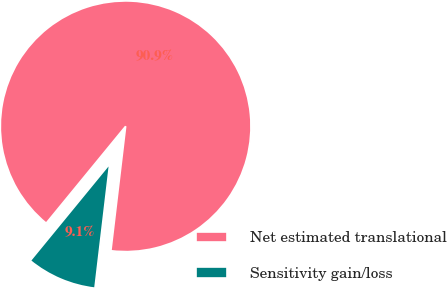Convert chart to OTSL. <chart><loc_0><loc_0><loc_500><loc_500><pie_chart><fcel>Net estimated translational<fcel>Sensitivity gain/loss<nl><fcel>90.95%<fcel>9.05%<nl></chart> 